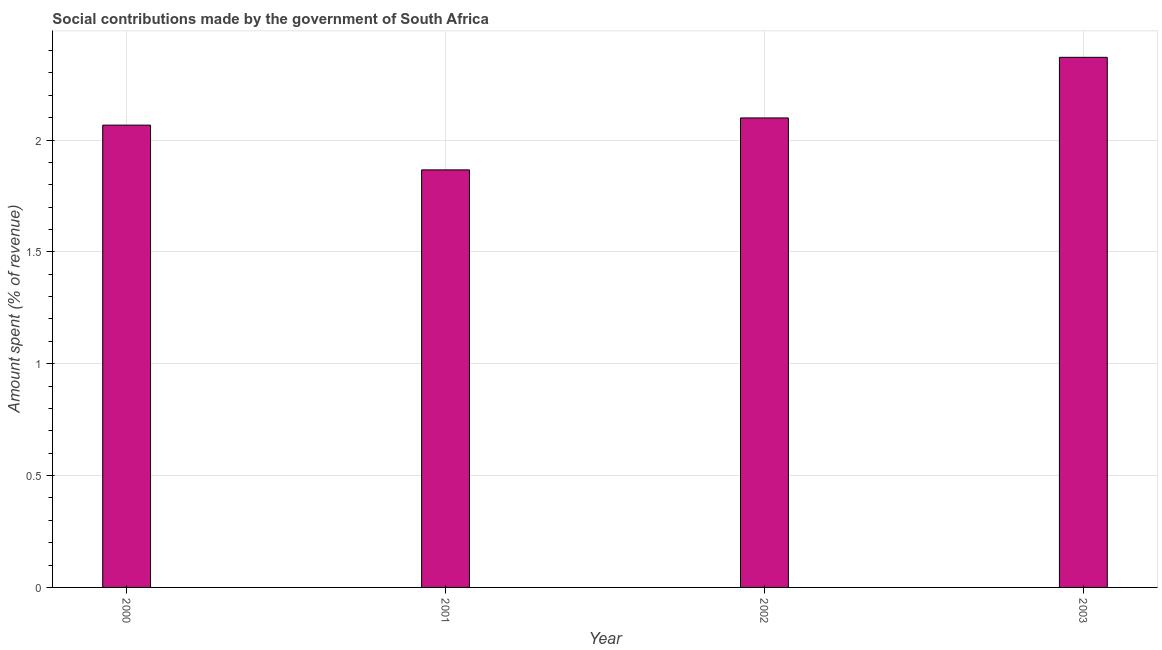What is the title of the graph?
Provide a short and direct response. Social contributions made by the government of South Africa. What is the label or title of the X-axis?
Offer a very short reply. Year. What is the label or title of the Y-axis?
Your response must be concise. Amount spent (% of revenue). What is the amount spent in making social contributions in 2002?
Make the answer very short. 2.1. Across all years, what is the maximum amount spent in making social contributions?
Your answer should be compact. 2.37. Across all years, what is the minimum amount spent in making social contributions?
Offer a terse response. 1.87. In which year was the amount spent in making social contributions minimum?
Offer a very short reply. 2001. What is the sum of the amount spent in making social contributions?
Give a very brief answer. 8.4. What is the difference between the amount spent in making social contributions in 2001 and 2002?
Keep it short and to the point. -0.23. What is the average amount spent in making social contributions per year?
Your response must be concise. 2.1. What is the median amount spent in making social contributions?
Make the answer very short. 2.08. In how many years, is the amount spent in making social contributions greater than 1.7 %?
Give a very brief answer. 4. What is the ratio of the amount spent in making social contributions in 2001 to that in 2003?
Offer a terse response. 0.79. Is the amount spent in making social contributions in 2002 less than that in 2003?
Offer a very short reply. Yes. What is the difference between the highest and the second highest amount spent in making social contributions?
Keep it short and to the point. 0.27. In how many years, is the amount spent in making social contributions greater than the average amount spent in making social contributions taken over all years?
Your response must be concise. 1. How many bars are there?
Provide a short and direct response. 4. Are all the bars in the graph horizontal?
Provide a short and direct response. No. What is the Amount spent (% of revenue) of 2000?
Offer a very short reply. 2.07. What is the Amount spent (% of revenue) in 2001?
Give a very brief answer. 1.87. What is the Amount spent (% of revenue) in 2002?
Your response must be concise. 2.1. What is the Amount spent (% of revenue) in 2003?
Give a very brief answer. 2.37. What is the difference between the Amount spent (% of revenue) in 2000 and 2001?
Provide a short and direct response. 0.2. What is the difference between the Amount spent (% of revenue) in 2000 and 2002?
Provide a succinct answer. -0.03. What is the difference between the Amount spent (% of revenue) in 2000 and 2003?
Keep it short and to the point. -0.3. What is the difference between the Amount spent (% of revenue) in 2001 and 2002?
Provide a succinct answer. -0.23. What is the difference between the Amount spent (% of revenue) in 2001 and 2003?
Keep it short and to the point. -0.5. What is the difference between the Amount spent (% of revenue) in 2002 and 2003?
Your answer should be compact. -0.27. What is the ratio of the Amount spent (% of revenue) in 2000 to that in 2001?
Keep it short and to the point. 1.11. What is the ratio of the Amount spent (% of revenue) in 2000 to that in 2003?
Your answer should be very brief. 0.87. What is the ratio of the Amount spent (% of revenue) in 2001 to that in 2002?
Keep it short and to the point. 0.89. What is the ratio of the Amount spent (% of revenue) in 2001 to that in 2003?
Provide a short and direct response. 0.79. What is the ratio of the Amount spent (% of revenue) in 2002 to that in 2003?
Your answer should be compact. 0.89. 